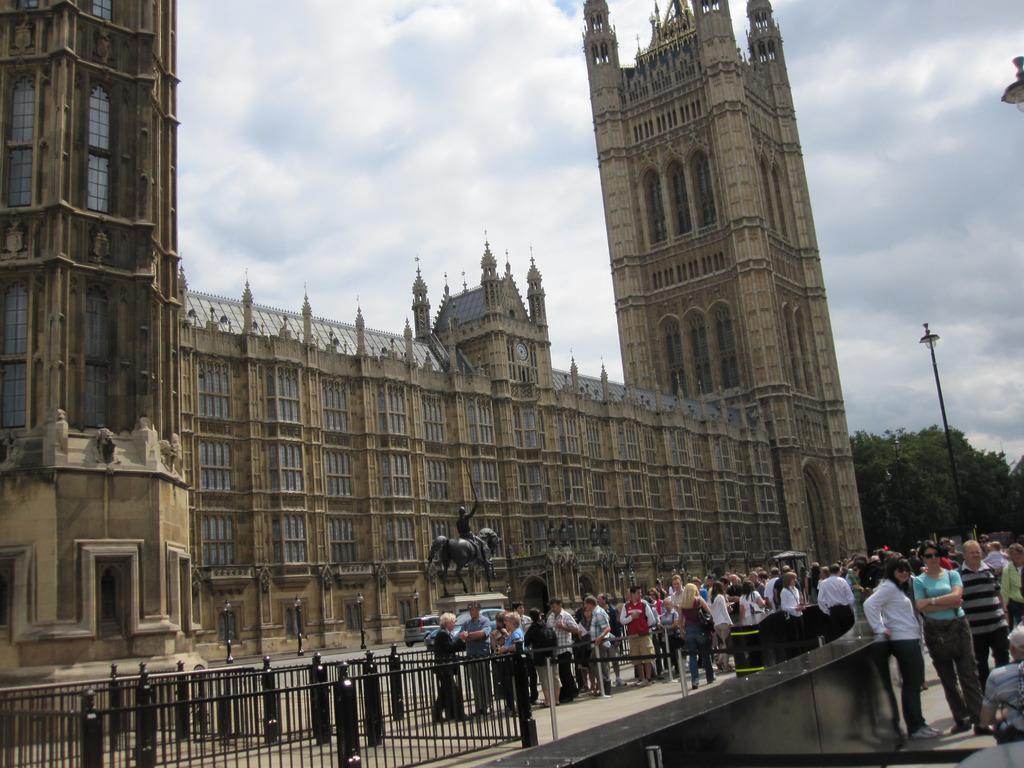Please provide a concise description of this image. In the picture we can see a historical building to it we can see a clock and near the building we can see a sculpture of a man sitting on the horse and besides we can see a car on the path and some people standing near the railing and besides we can see some poles with lights and beside the building we can see trees and behind it we can see a sky with clouds. 